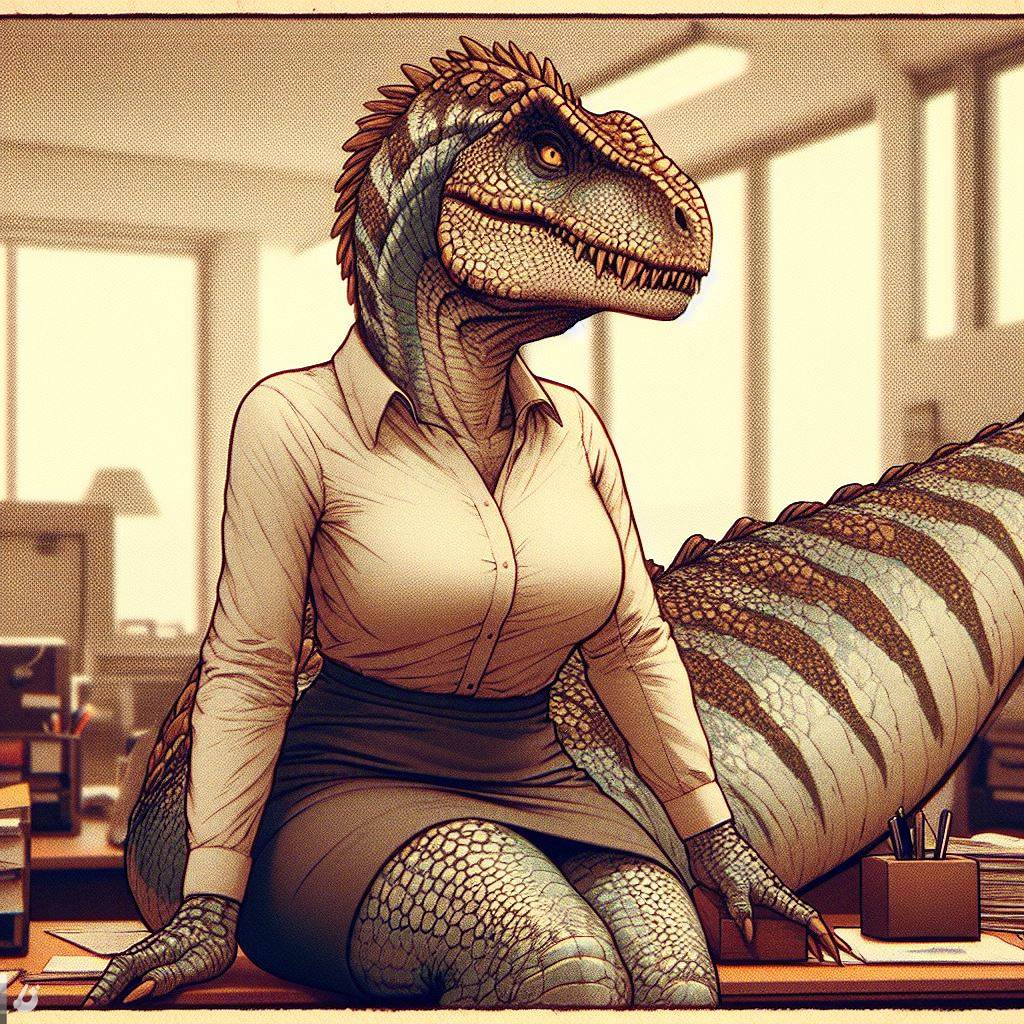describe this image. The image shows a female dinosaur wearing a business suit. She is sitting at a desk and looking at the camera. The dinosaur has green scales, a long tail, and sharp teeth. She is wearing a white blouse, a brown skirt, and a pair of black high heels. The dinosaur is sitting in a modern office, surrounded by papers and files. 